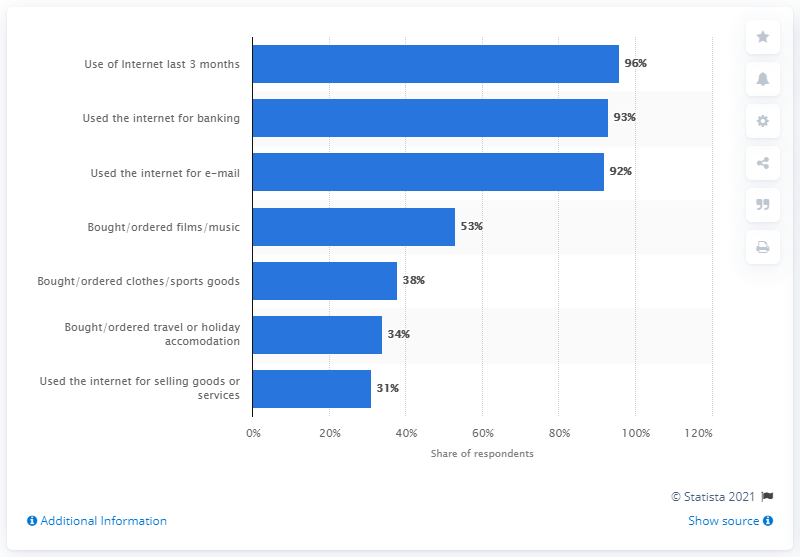Mention a couple of crucial points in this snapshot. In 2020, 93% of Norwegians used the internet for banking. In 2019, 92% of Norwegians reported using the internet less than once a week. In 2020, 92% of Norwegians used the internet for emails. 